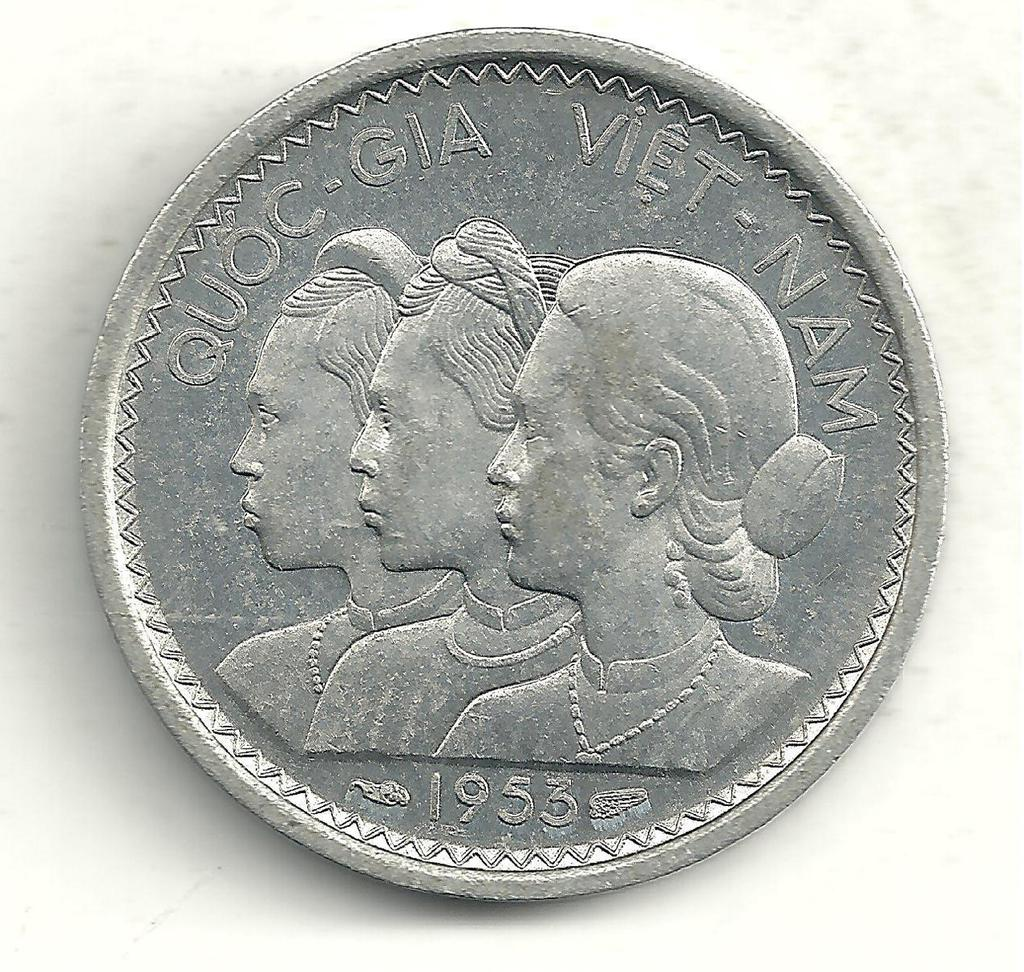Provide a one-sentence caption for the provided image. Quoc gia vietnam silver coin with three ladies on the front. 